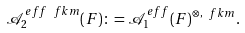<formula> <loc_0><loc_0><loc_500><loc_500>\mathcal { A } ^ { e f f \ f k { m } } _ { 2 } ( F ) \colon = \mathcal { A } ^ { e f f } _ { 1 } ( F ) ^ { \otimes , \ f k { m } } .</formula> 